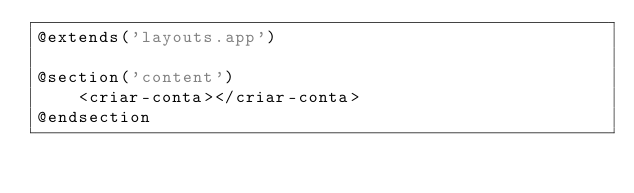Convert code to text. <code><loc_0><loc_0><loc_500><loc_500><_PHP_>@extends('layouts.app')

@section('content')
    <criar-conta></criar-conta>
@endsection</code> 